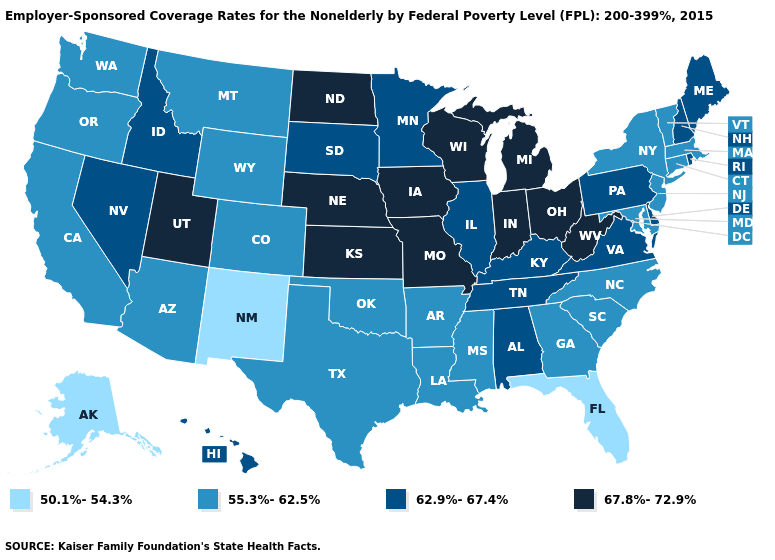Does Montana have a higher value than Minnesota?
Keep it brief. No. What is the value of North Dakota?
Write a very short answer. 67.8%-72.9%. What is the lowest value in the USA?
Keep it brief. 50.1%-54.3%. Does the first symbol in the legend represent the smallest category?
Concise answer only. Yes. Name the states that have a value in the range 67.8%-72.9%?
Quick response, please. Indiana, Iowa, Kansas, Michigan, Missouri, Nebraska, North Dakota, Ohio, Utah, West Virginia, Wisconsin. What is the value of Kentucky?
Short answer required. 62.9%-67.4%. Does Georgia have a higher value than Florida?
Answer briefly. Yes. Which states have the lowest value in the USA?
Answer briefly. Alaska, Florida, New Mexico. What is the value of Maryland?
Answer briefly. 55.3%-62.5%. Which states have the lowest value in the USA?
Quick response, please. Alaska, Florida, New Mexico. What is the lowest value in states that border Nebraska?
Keep it brief. 55.3%-62.5%. Which states hav the highest value in the West?
Write a very short answer. Utah. What is the lowest value in the USA?
Concise answer only. 50.1%-54.3%. Which states have the highest value in the USA?
Quick response, please. Indiana, Iowa, Kansas, Michigan, Missouri, Nebraska, North Dakota, Ohio, Utah, West Virginia, Wisconsin. Which states hav the highest value in the West?
Concise answer only. Utah. 